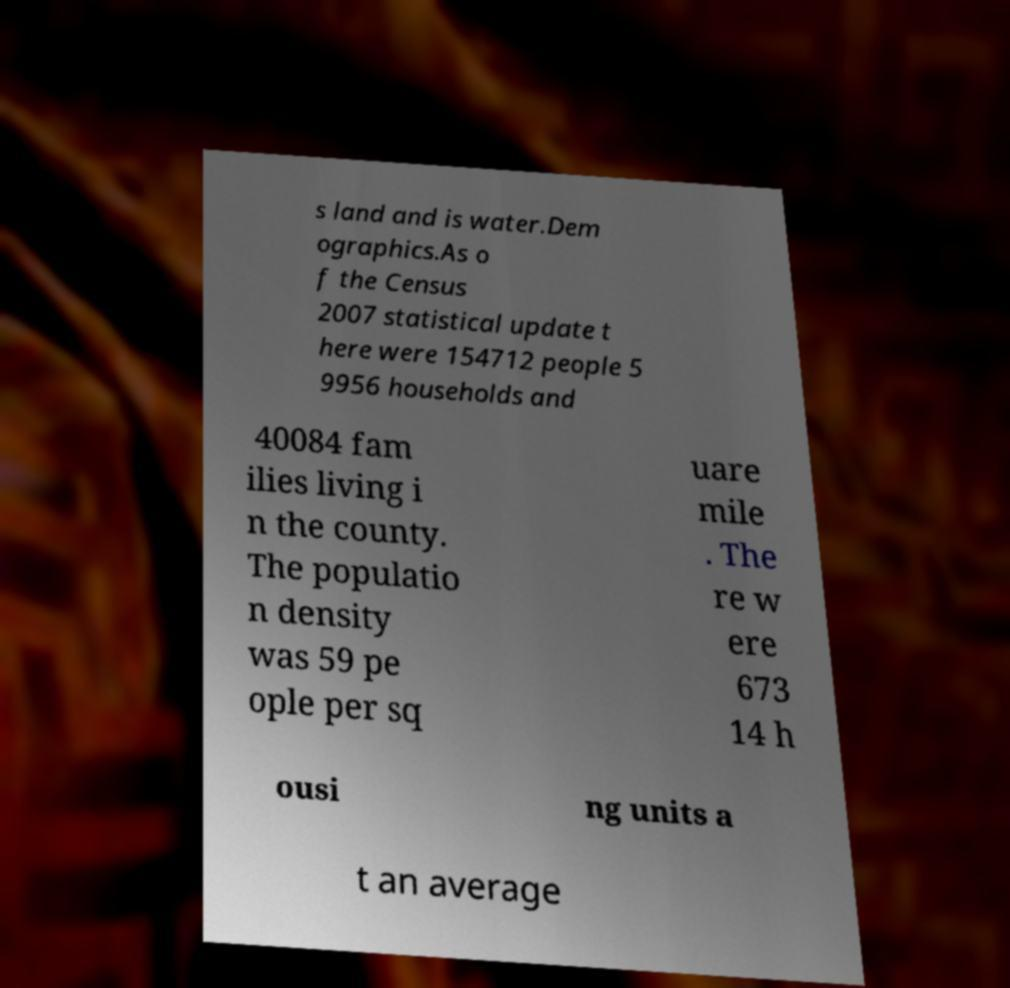I need the written content from this picture converted into text. Can you do that? s land and is water.Dem ographics.As o f the Census 2007 statistical update t here were 154712 people 5 9956 households and 40084 fam ilies living i n the county. The populatio n density was 59 pe ople per sq uare mile . The re w ere 673 14 h ousi ng units a t an average 